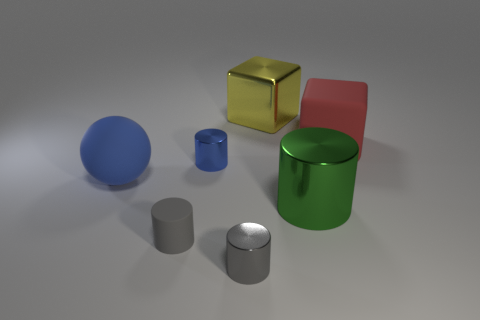Subtract all purple cylinders. Subtract all yellow spheres. How many cylinders are left? 4 Add 1 blue cylinders. How many objects exist? 8 Subtract all blocks. How many objects are left? 5 Subtract 0 cyan cubes. How many objects are left? 7 Subtract all big blue spheres. Subtract all big metal cylinders. How many objects are left? 5 Add 7 green shiny objects. How many green shiny objects are left? 8 Add 7 big cylinders. How many big cylinders exist? 8 